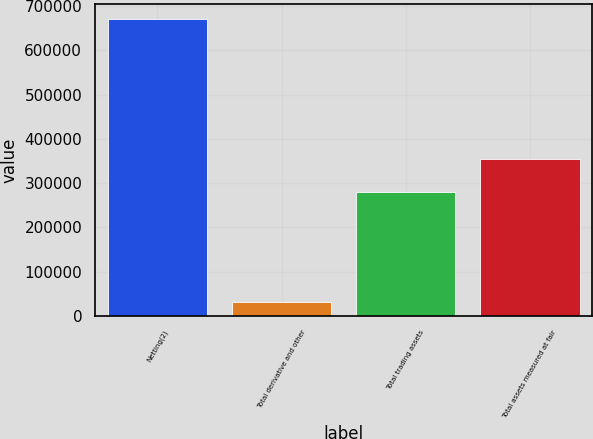Convert chart to OTSL. <chart><loc_0><loc_0><loc_500><loc_500><bar_chart><fcel>Netting(2)<fcel>Total derivative and other<fcel>Total trading assets<fcel>Total assets measured at fair<nl><fcel>670551<fcel>32467<fcel>280744<fcel>355556<nl></chart> 